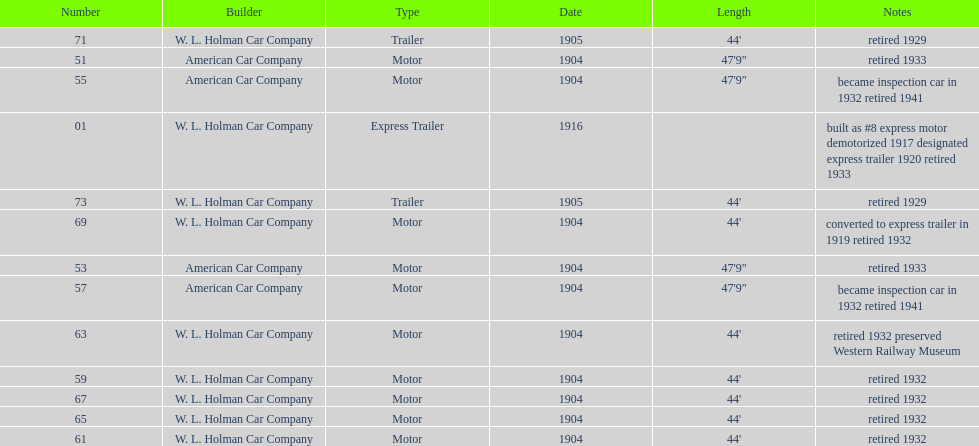What was the number of cars built by american car company? 4. 